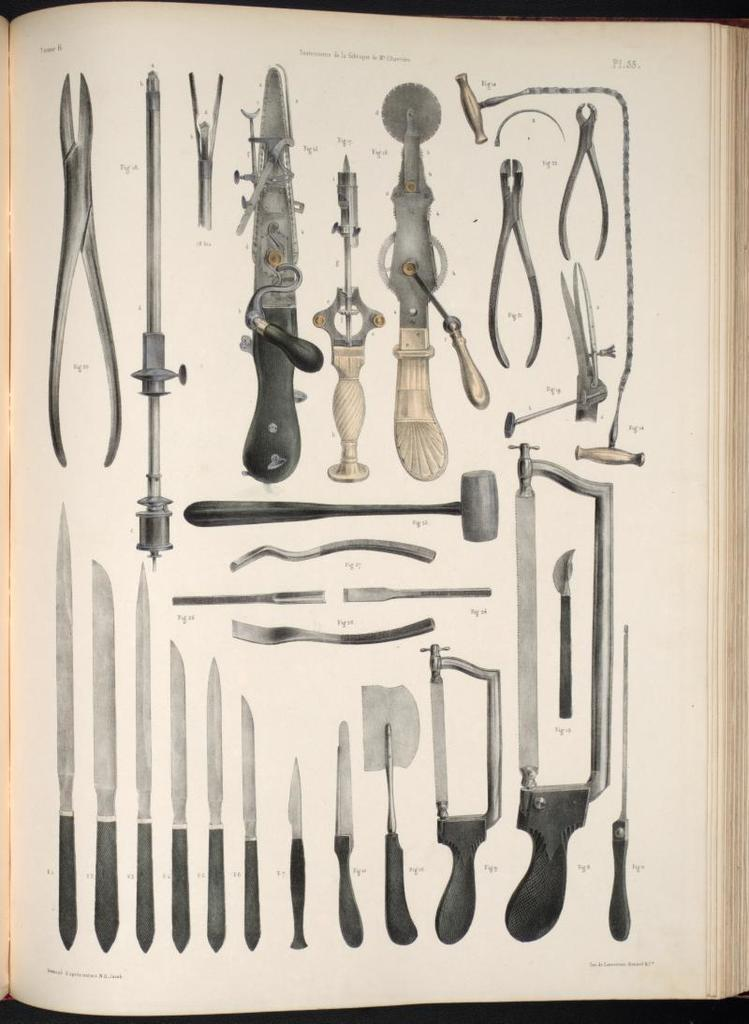What is the main object in the image? There is a book in the image. What type of content is in the book? The book contains images of knives and other instruments. How many types of knives are shown in the images? There are different types of knives in the images. What other tool is present in the images? There are cutters in the images. Can you describe the position of the hammer in the images? There is a hammer in the middle of the images. How many icicles are hanging from the hammer in the image? There are no icicles present in the image; it features a book with images of knives, cutters, and a hammer. What fact can be learned about the act of using a hammer from the image? The image does not show the act of using a hammer, so no fact about its use can be learned from the image. 